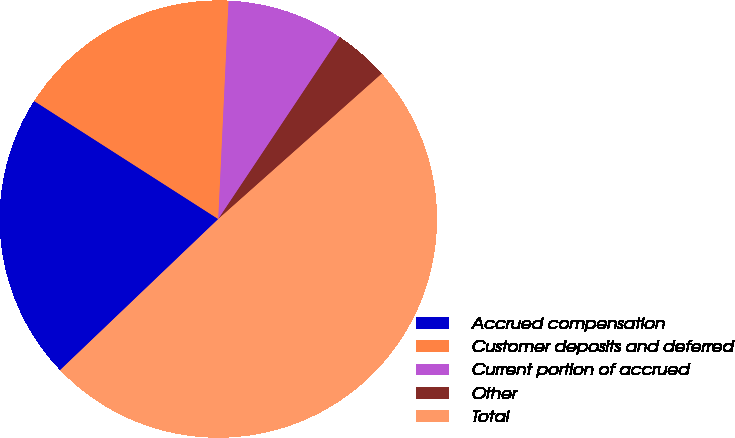Convert chart to OTSL. <chart><loc_0><loc_0><loc_500><loc_500><pie_chart><fcel>Accrued compensation<fcel>Customer deposits and deferred<fcel>Current portion of accrued<fcel>Other<fcel>Total<nl><fcel>21.21%<fcel>16.68%<fcel>8.61%<fcel>4.07%<fcel>49.43%<nl></chart> 